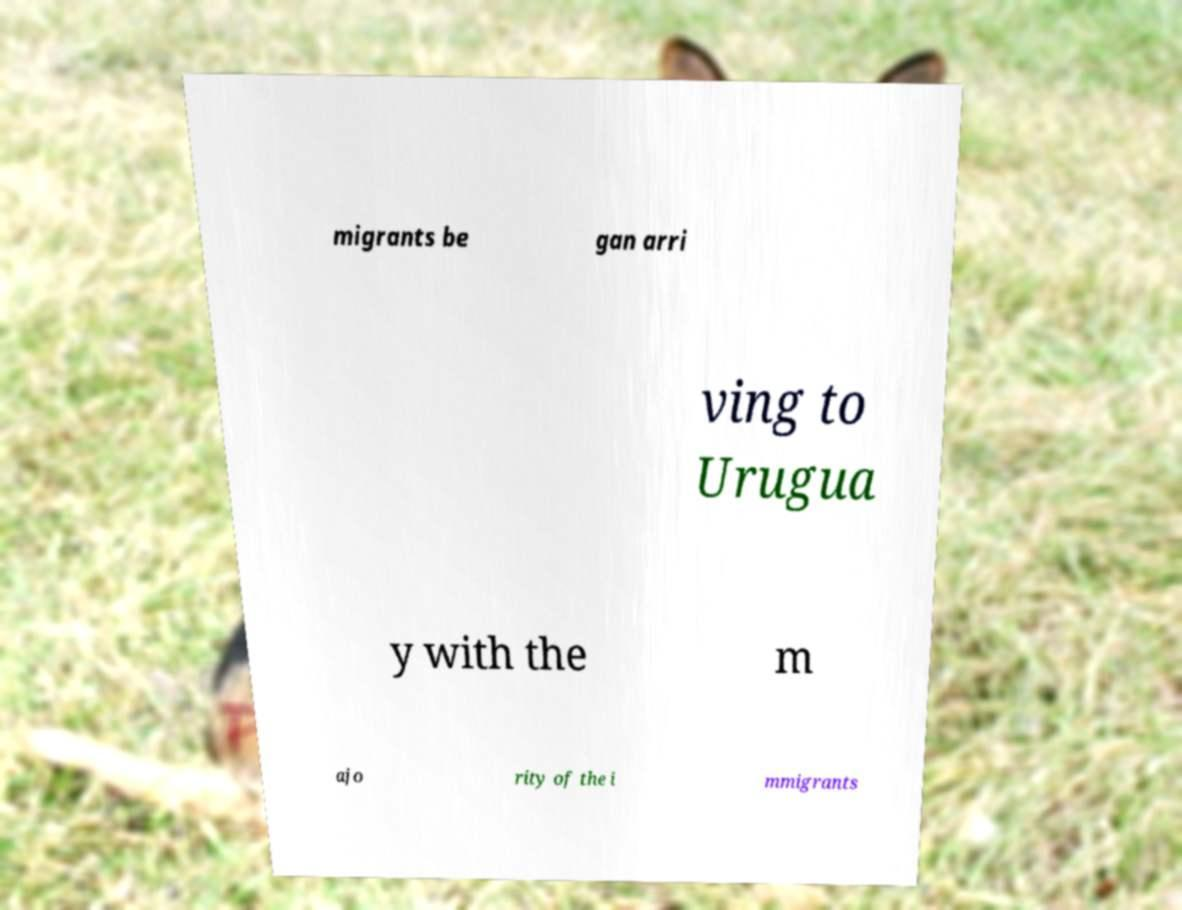Can you read and provide the text displayed in the image?This photo seems to have some interesting text. Can you extract and type it out for me? migrants be gan arri ving to Urugua y with the m ajo rity of the i mmigrants 